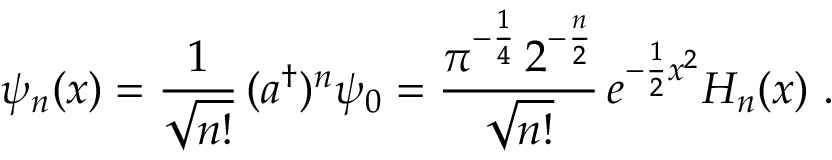<formula> <loc_0><loc_0><loc_500><loc_500>\psi _ { n } ( x ) = \frac { 1 } \sqrt { n ! } } \, ( a ^ { \dag } ) ^ { n } \psi _ { 0 } = \frac { \pi ^ { - \frac { 1 } { 4 } } \, 2 ^ { - \frac { n } { 2 } } } { \sqrt { n ! } } \, e ^ { - \frac { 1 } { 2 } x ^ { 2 } } H _ { n } ( x ) \ .</formula> 